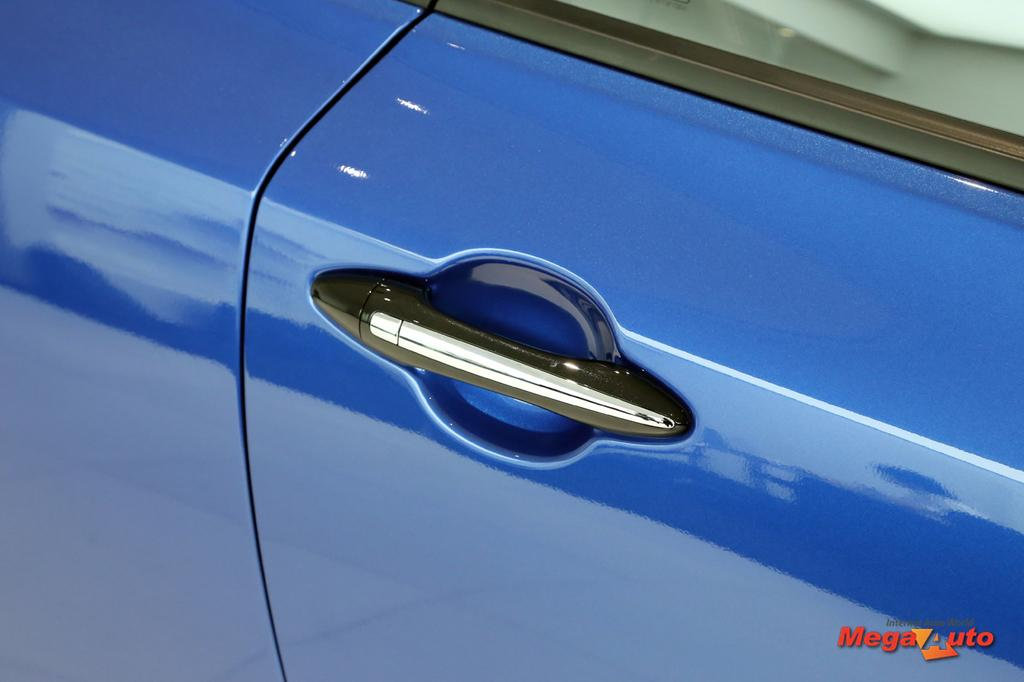What is the main subject of the image? The main subject of the image is the door of a vehicle. Can you describe any text visible in the image? Yes, there is text visible at the bottom of the image. How many songs are playing in the room depicted in the image? There is no room or any indication of songs playing in the image; it only features the door of a vehicle and text at the bottom. 